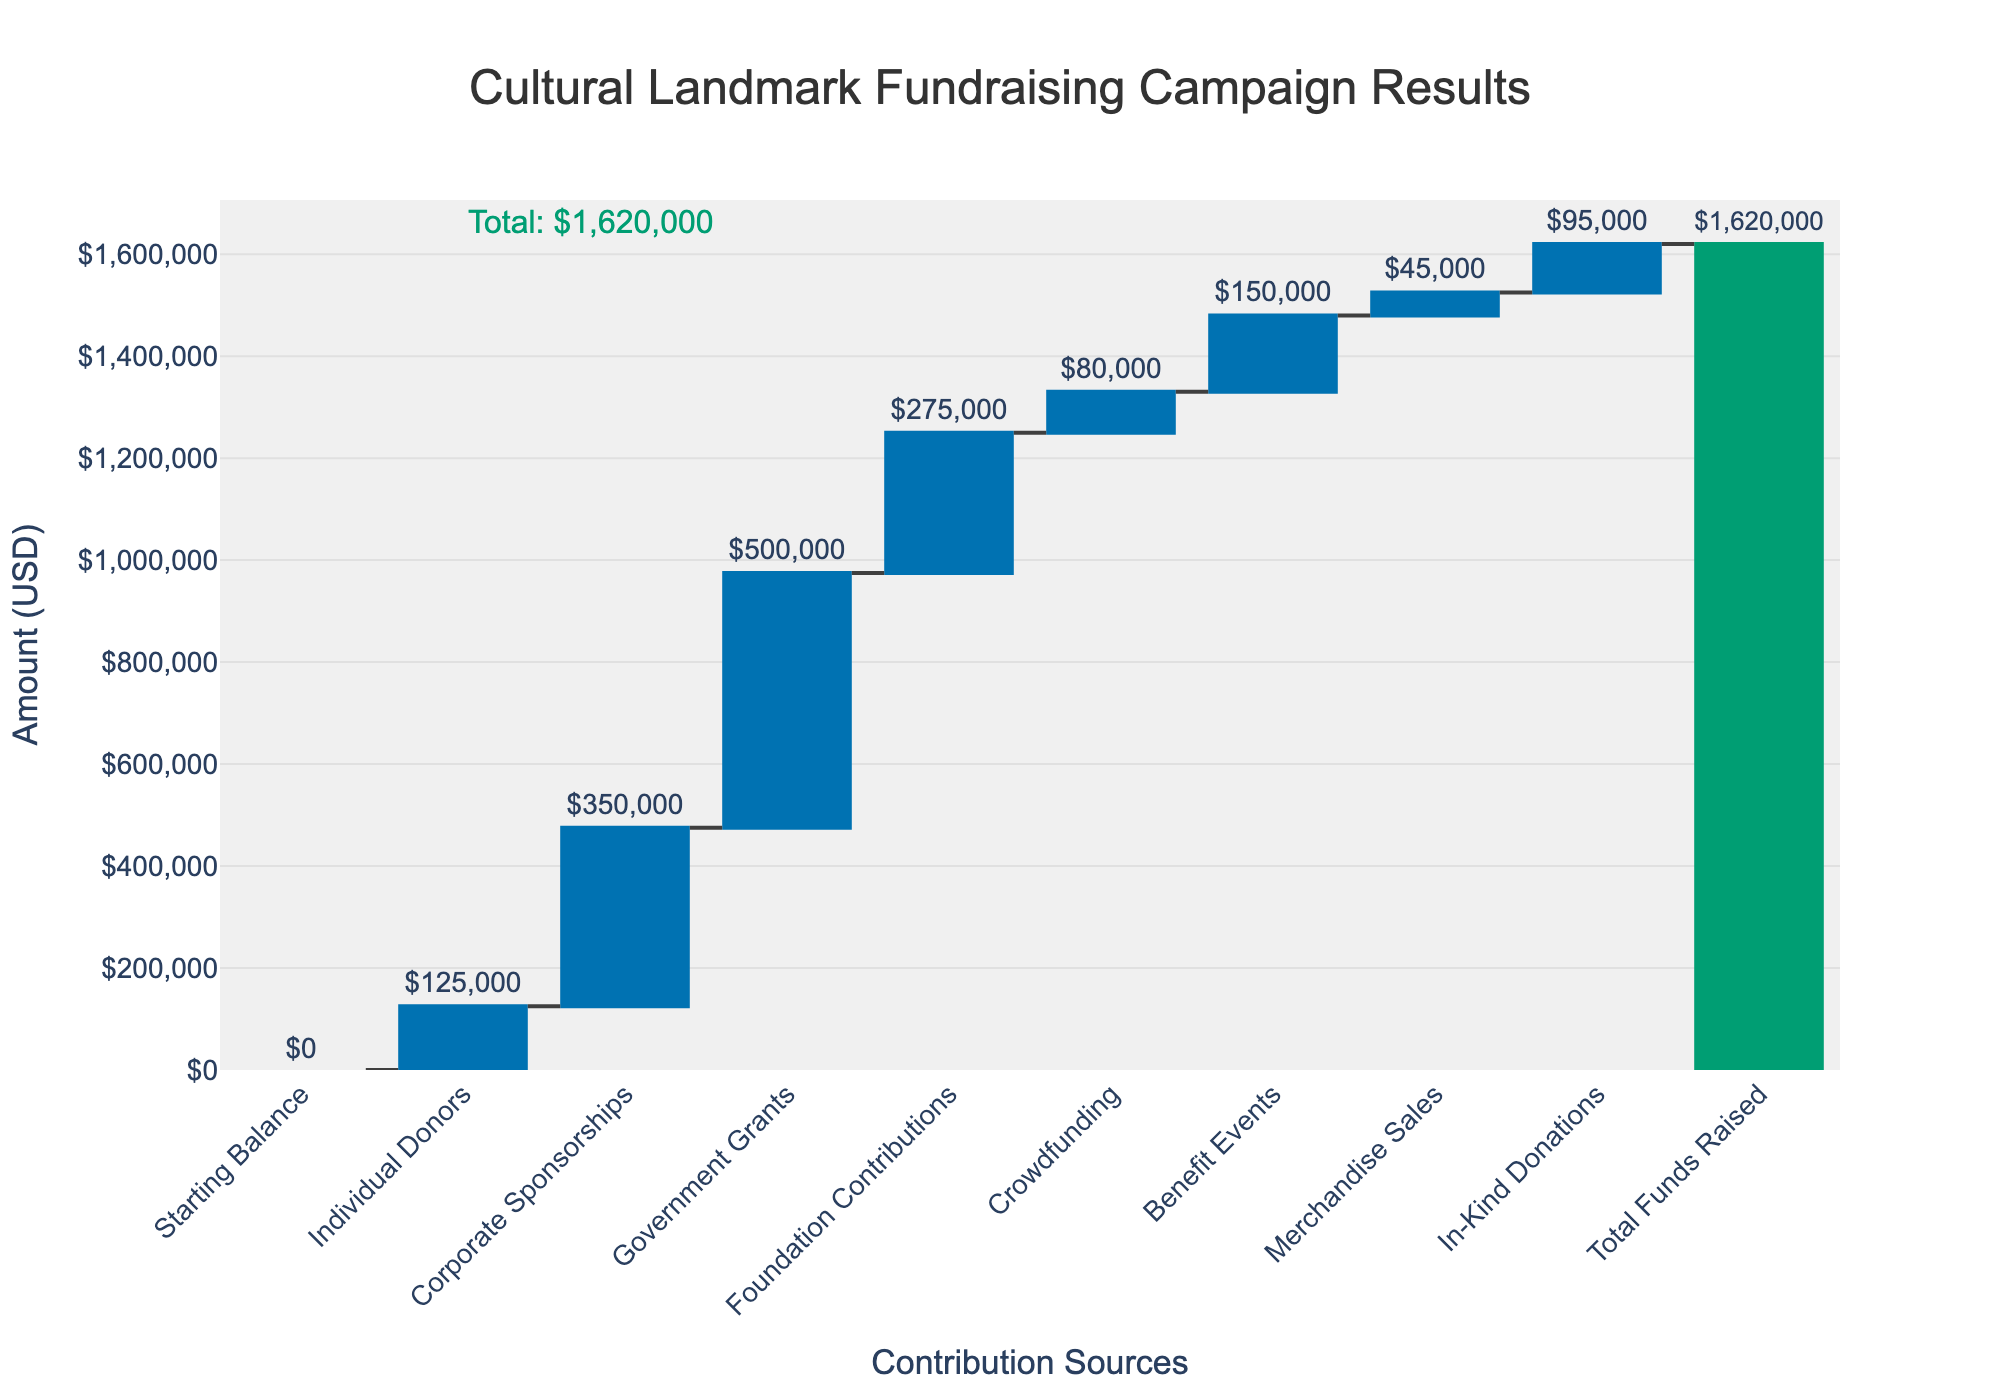What is the total amount of funds raised shown in the figure? The total amount of funds raised is displayed at the top or alongside the final column in the Waterfall Chart, marked as the cumulative total.
Answer: $1,620,000 Which contribution source provided the highest amount? By inspecting the height of the columns representing each contribution source, the highest column corresponds to Government Grants.
Answer: Government Grants How much did Individual Donors contribute? The height of the column representing Individual Donors shows their contribution.
Answer: $125,000 What is the combined contribution of Corporate Sponsorships and Benefit Events? Add the amounts from the columns for Corporate Sponsorships and Benefit Events: $350,000 + $150,000 = $500,000.
Answer: $500,000 Which contribution source(s) provided less than $100,000? Compare the heights of the columns; In-Kind Donations ($95,000), Merchandise Sales ($45,000), and Crowdfunding ($80,000) all contribute less than $100,000.
Answer: In-Kind Donations, Merchandise Sales, Crowdfunding What is the difference between the contributions from Foundation Contributions and Crowdfunding? Subtract the amount of Crowdfunding from Foundation Contributions: $275,000 - $80,000 = $195,000.
Answer: $195,000 If the campaign had only Government Grants and Benefit Events, what would be the total funds raised? Summing the contributions from Government Grants and Benefit Events: $500,000 + $150,000 = $650,000.
Answer: $650,000 Among the sources contributing more than $100,000, which one gave the smallest amount? Comparing the sources contributing more than $100,000, Individual Donors contributed the smallest amount of those sources.
Answer: Individual Donors What would be the total if Corporate Sponsorships were excluded? Subtract Corporate Sponsorships from the total: $1,620,000 - $350,000 = $1,270,000.
Answer: $1,270,000 Which contribution sources increased the total more noticeably according to the figure’s color coding? The column colors indicate increases (e.g., blue shades); significant increases are seen with Government Grants, Corporate Sponsorships, and Foundation Contributions.
Answer: Government Grants, Corporate Sponsorships, Foundation Contributions 